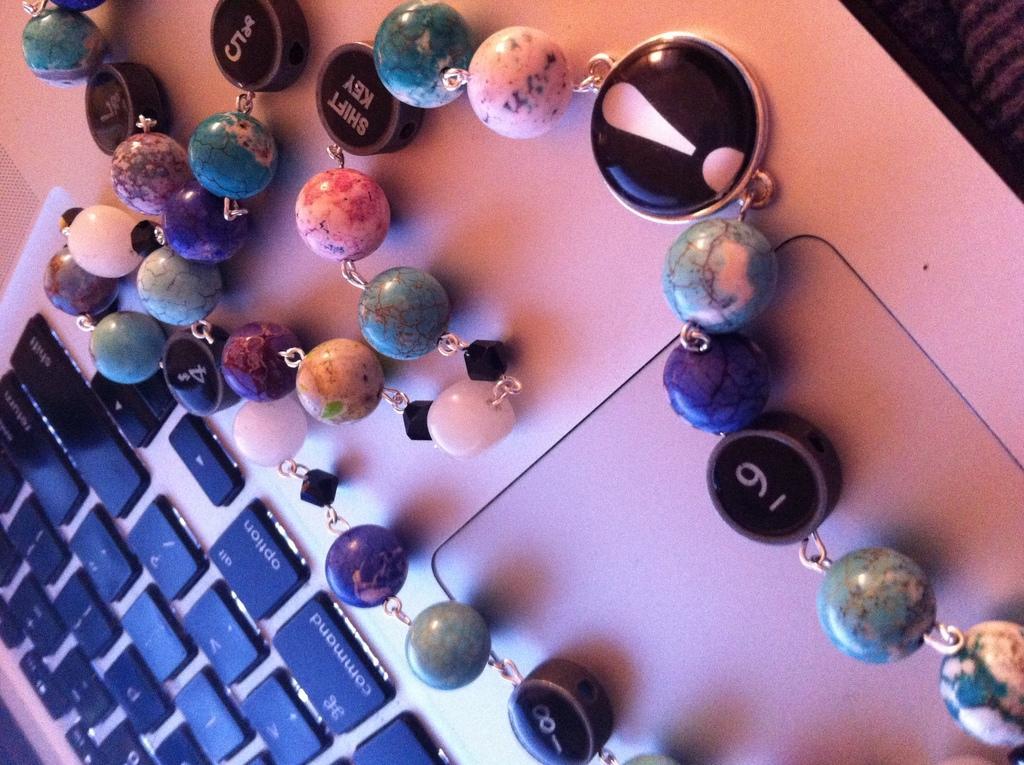Describe this image in one or two sentences. In this picture there is an ornament on the laptop and there is text and there are numbers on the ornament and there is text and there are symbols on the keys. 